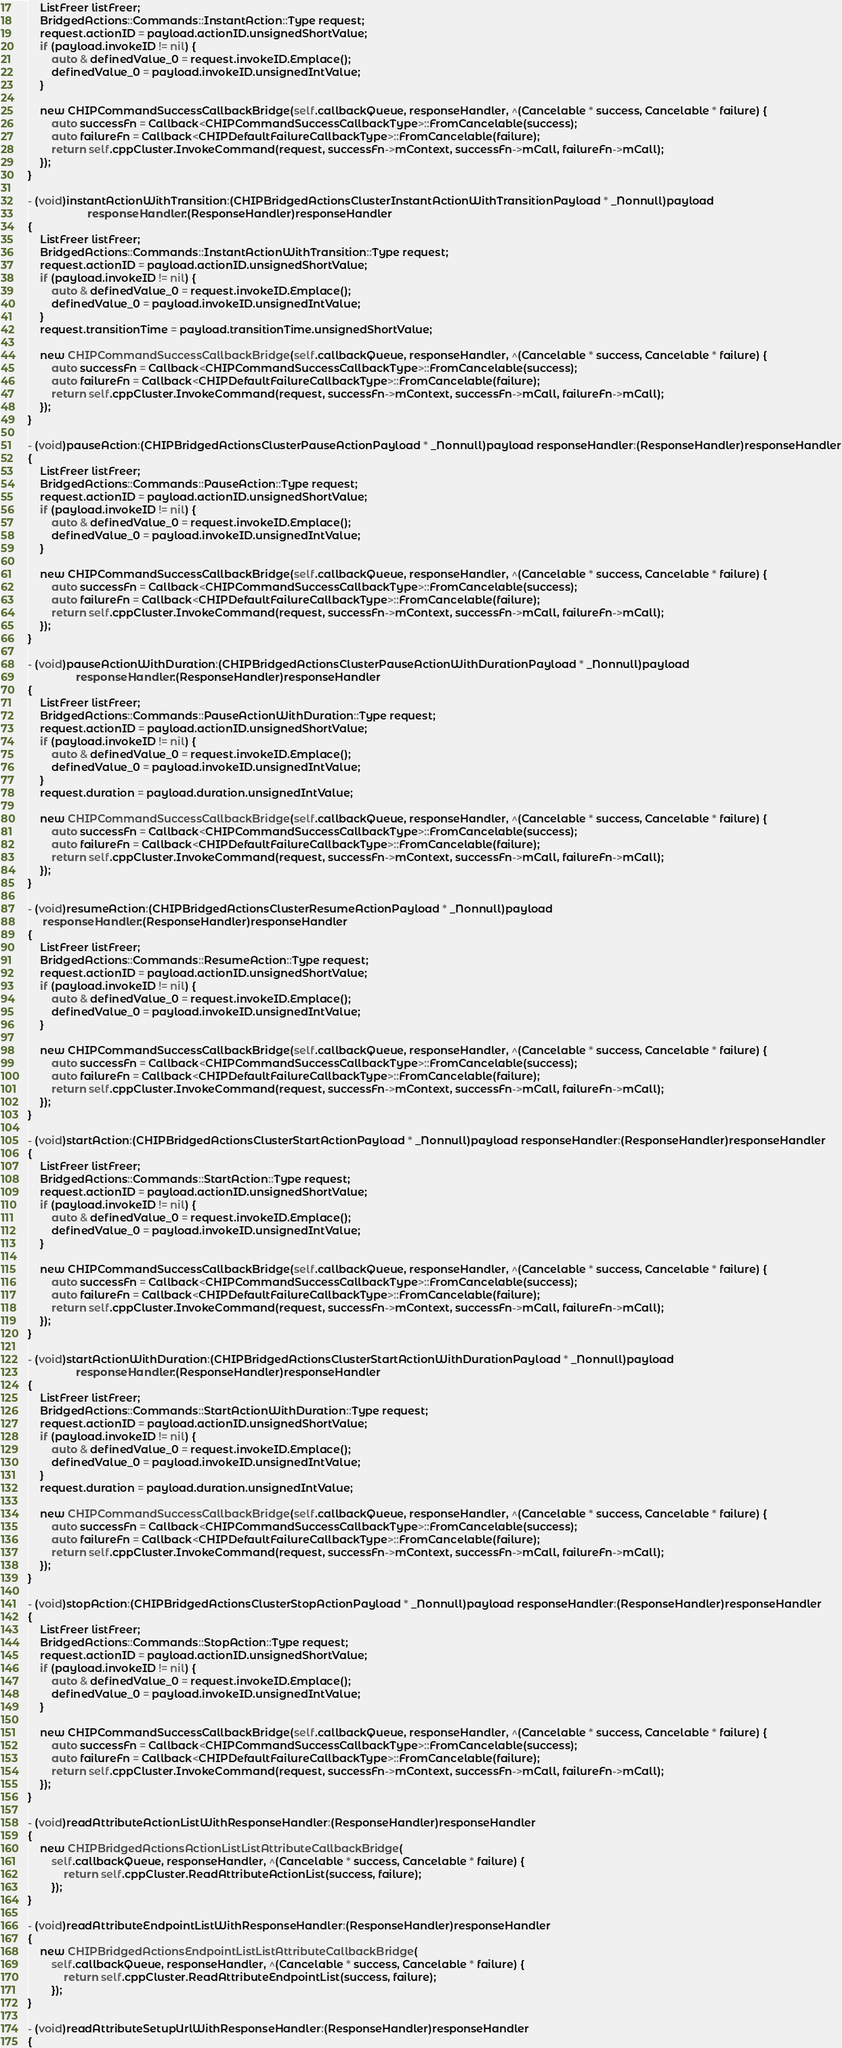Convert code to text. <code><loc_0><loc_0><loc_500><loc_500><_ObjectiveC_>    ListFreer listFreer;
    BridgedActions::Commands::InstantAction::Type request;
    request.actionID = payload.actionID.unsignedShortValue;
    if (payload.invokeID != nil) {
        auto & definedValue_0 = request.invokeID.Emplace();
        definedValue_0 = payload.invokeID.unsignedIntValue;
    }

    new CHIPCommandSuccessCallbackBridge(self.callbackQueue, responseHandler, ^(Cancelable * success, Cancelable * failure) {
        auto successFn = Callback<CHIPCommandSuccessCallbackType>::FromCancelable(success);
        auto failureFn = Callback<CHIPDefaultFailureCallbackType>::FromCancelable(failure);
        return self.cppCluster.InvokeCommand(request, successFn->mContext, successFn->mCall, failureFn->mCall);
    });
}

- (void)instantActionWithTransition:(CHIPBridgedActionsClusterInstantActionWithTransitionPayload * _Nonnull)payload
                    responseHandler:(ResponseHandler)responseHandler
{
    ListFreer listFreer;
    BridgedActions::Commands::InstantActionWithTransition::Type request;
    request.actionID = payload.actionID.unsignedShortValue;
    if (payload.invokeID != nil) {
        auto & definedValue_0 = request.invokeID.Emplace();
        definedValue_0 = payload.invokeID.unsignedIntValue;
    }
    request.transitionTime = payload.transitionTime.unsignedShortValue;

    new CHIPCommandSuccessCallbackBridge(self.callbackQueue, responseHandler, ^(Cancelable * success, Cancelable * failure) {
        auto successFn = Callback<CHIPCommandSuccessCallbackType>::FromCancelable(success);
        auto failureFn = Callback<CHIPDefaultFailureCallbackType>::FromCancelable(failure);
        return self.cppCluster.InvokeCommand(request, successFn->mContext, successFn->mCall, failureFn->mCall);
    });
}

- (void)pauseAction:(CHIPBridgedActionsClusterPauseActionPayload * _Nonnull)payload responseHandler:(ResponseHandler)responseHandler
{
    ListFreer listFreer;
    BridgedActions::Commands::PauseAction::Type request;
    request.actionID = payload.actionID.unsignedShortValue;
    if (payload.invokeID != nil) {
        auto & definedValue_0 = request.invokeID.Emplace();
        definedValue_0 = payload.invokeID.unsignedIntValue;
    }

    new CHIPCommandSuccessCallbackBridge(self.callbackQueue, responseHandler, ^(Cancelable * success, Cancelable * failure) {
        auto successFn = Callback<CHIPCommandSuccessCallbackType>::FromCancelable(success);
        auto failureFn = Callback<CHIPDefaultFailureCallbackType>::FromCancelable(failure);
        return self.cppCluster.InvokeCommand(request, successFn->mContext, successFn->mCall, failureFn->mCall);
    });
}

- (void)pauseActionWithDuration:(CHIPBridgedActionsClusterPauseActionWithDurationPayload * _Nonnull)payload
                responseHandler:(ResponseHandler)responseHandler
{
    ListFreer listFreer;
    BridgedActions::Commands::PauseActionWithDuration::Type request;
    request.actionID = payload.actionID.unsignedShortValue;
    if (payload.invokeID != nil) {
        auto & definedValue_0 = request.invokeID.Emplace();
        definedValue_0 = payload.invokeID.unsignedIntValue;
    }
    request.duration = payload.duration.unsignedIntValue;

    new CHIPCommandSuccessCallbackBridge(self.callbackQueue, responseHandler, ^(Cancelable * success, Cancelable * failure) {
        auto successFn = Callback<CHIPCommandSuccessCallbackType>::FromCancelable(success);
        auto failureFn = Callback<CHIPDefaultFailureCallbackType>::FromCancelable(failure);
        return self.cppCluster.InvokeCommand(request, successFn->mContext, successFn->mCall, failureFn->mCall);
    });
}

- (void)resumeAction:(CHIPBridgedActionsClusterResumeActionPayload * _Nonnull)payload
     responseHandler:(ResponseHandler)responseHandler
{
    ListFreer listFreer;
    BridgedActions::Commands::ResumeAction::Type request;
    request.actionID = payload.actionID.unsignedShortValue;
    if (payload.invokeID != nil) {
        auto & definedValue_0 = request.invokeID.Emplace();
        definedValue_0 = payload.invokeID.unsignedIntValue;
    }

    new CHIPCommandSuccessCallbackBridge(self.callbackQueue, responseHandler, ^(Cancelable * success, Cancelable * failure) {
        auto successFn = Callback<CHIPCommandSuccessCallbackType>::FromCancelable(success);
        auto failureFn = Callback<CHIPDefaultFailureCallbackType>::FromCancelable(failure);
        return self.cppCluster.InvokeCommand(request, successFn->mContext, successFn->mCall, failureFn->mCall);
    });
}

- (void)startAction:(CHIPBridgedActionsClusterStartActionPayload * _Nonnull)payload responseHandler:(ResponseHandler)responseHandler
{
    ListFreer listFreer;
    BridgedActions::Commands::StartAction::Type request;
    request.actionID = payload.actionID.unsignedShortValue;
    if (payload.invokeID != nil) {
        auto & definedValue_0 = request.invokeID.Emplace();
        definedValue_0 = payload.invokeID.unsignedIntValue;
    }

    new CHIPCommandSuccessCallbackBridge(self.callbackQueue, responseHandler, ^(Cancelable * success, Cancelable * failure) {
        auto successFn = Callback<CHIPCommandSuccessCallbackType>::FromCancelable(success);
        auto failureFn = Callback<CHIPDefaultFailureCallbackType>::FromCancelable(failure);
        return self.cppCluster.InvokeCommand(request, successFn->mContext, successFn->mCall, failureFn->mCall);
    });
}

- (void)startActionWithDuration:(CHIPBridgedActionsClusterStartActionWithDurationPayload * _Nonnull)payload
                responseHandler:(ResponseHandler)responseHandler
{
    ListFreer listFreer;
    BridgedActions::Commands::StartActionWithDuration::Type request;
    request.actionID = payload.actionID.unsignedShortValue;
    if (payload.invokeID != nil) {
        auto & definedValue_0 = request.invokeID.Emplace();
        definedValue_0 = payload.invokeID.unsignedIntValue;
    }
    request.duration = payload.duration.unsignedIntValue;

    new CHIPCommandSuccessCallbackBridge(self.callbackQueue, responseHandler, ^(Cancelable * success, Cancelable * failure) {
        auto successFn = Callback<CHIPCommandSuccessCallbackType>::FromCancelable(success);
        auto failureFn = Callback<CHIPDefaultFailureCallbackType>::FromCancelable(failure);
        return self.cppCluster.InvokeCommand(request, successFn->mContext, successFn->mCall, failureFn->mCall);
    });
}

- (void)stopAction:(CHIPBridgedActionsClusterStopActionPayload * _Nonnull)payload responseHandler:(ResponseHandler)responseHandler
{
    ListFreer listFreer;
    BridgedActions::Commands::StopAction::Type request;
    request.actionID = payload.actionID.unsignedShortValue;
    if (payload.invokeID != nil) {
        auto & definedValue_0 = request.invokeID.Emplace();
        definedValue_0 = payload.invokeID.unsignedIntValue;
    }

    new CHIPCommandSuccessCallbackBridge(self.callbackQueue, responseHandler, ^(Cancelable * success, Cancelable * failure) {
        auto successFn = Callback<CHIPCommandSuccessCallbackType>::FromCancelable(success);
        auto failureFn = Callback<CHIPDefaultFailureCallbackType>::FromCancelable(failure);
        return self.cppCluster.InvokeCommand(request, successFn->mContext, successFn->mCall, failureFn->mCall);
    });
}

- (void)readAttributeActionListWithResponseHandler:(ResponseHandler)responseHandler
{
    new CHIPBridgedActionsActionListListAttributeCallbackBridge(
        self.callbackQueue, responseHandler, ^(Cancelable * success, Cancelable * failure) {
            return self.cppCluster.ReadAttributeActionList(success, failure);
        });
}

- (void)readAttributeEndpointListWithResponseHandler:(ResponseHandler)responseHandler
{
    new CHIPBridgedActionsEndpointListListAttributeCallbackBridge(
        self.callbackQueue, responseHandler, ^(Cancelable * success, Cancelable * failure) {
            return self.cppCluster.ReadAttributeEndpointList(success, failure);
        });
}

- (void)readAttributeSetupUrlWithResponseHandler:(ResponseHandler)responseHandler
{</code> 